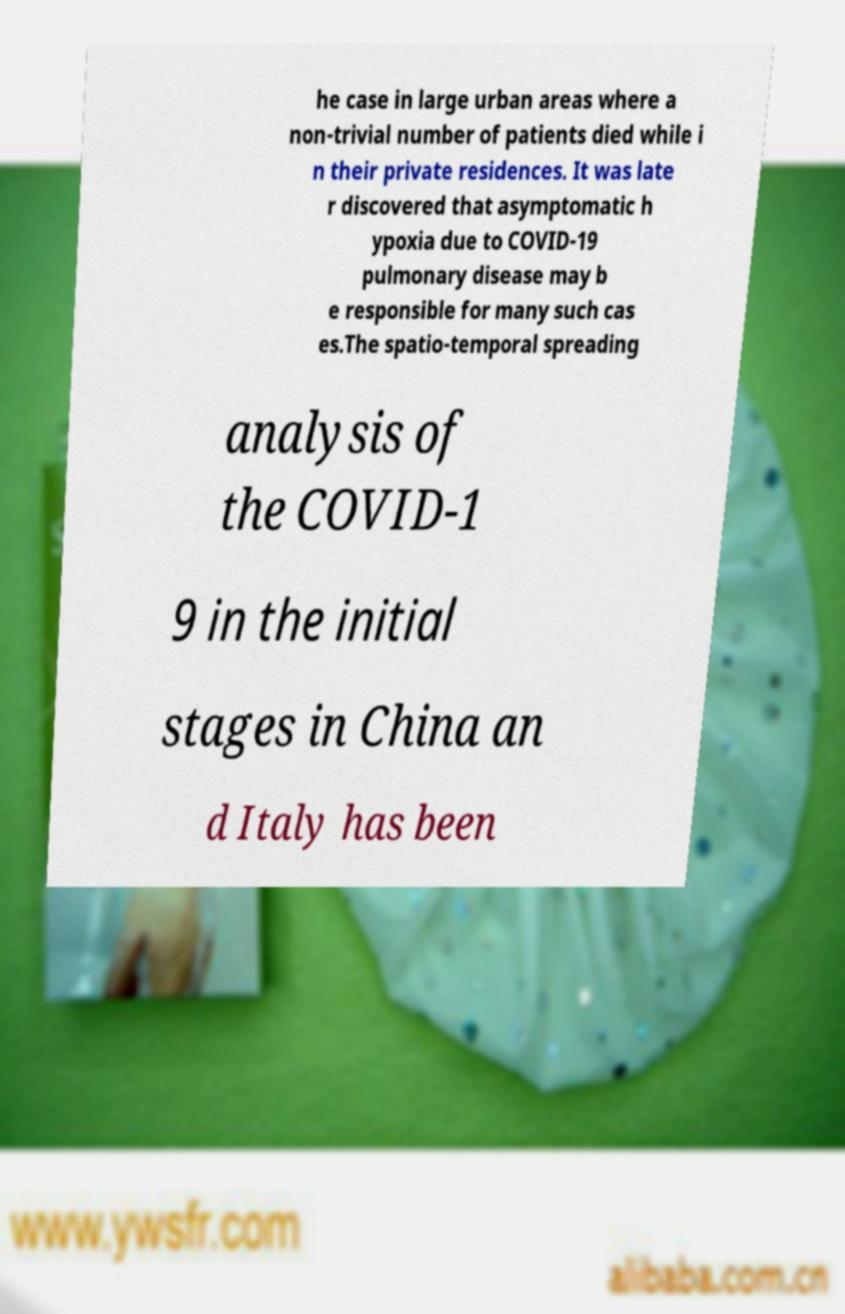What messages or text are displayed in this image? I need them in a readable, typed format. he case in large urban areas where a non-trivial number of patients died while i n their private residences. It was late r discovered that asymptomatic h ypoxia due to COVID-19 pulmonary disease may b e responsible for many such cas es.The spatio-temporal spreading analysis of the COVID-1 9 in the initial stages in China an d Italy has been 